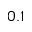Convert formula to latex. <formula><loc_0><loc_0><loc_500><loc_500>0 . 1</formula> 